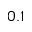Convert formula to latex. <formula><loc_0><loc_0><loc_500><loc_500>0 . 1</formula> 